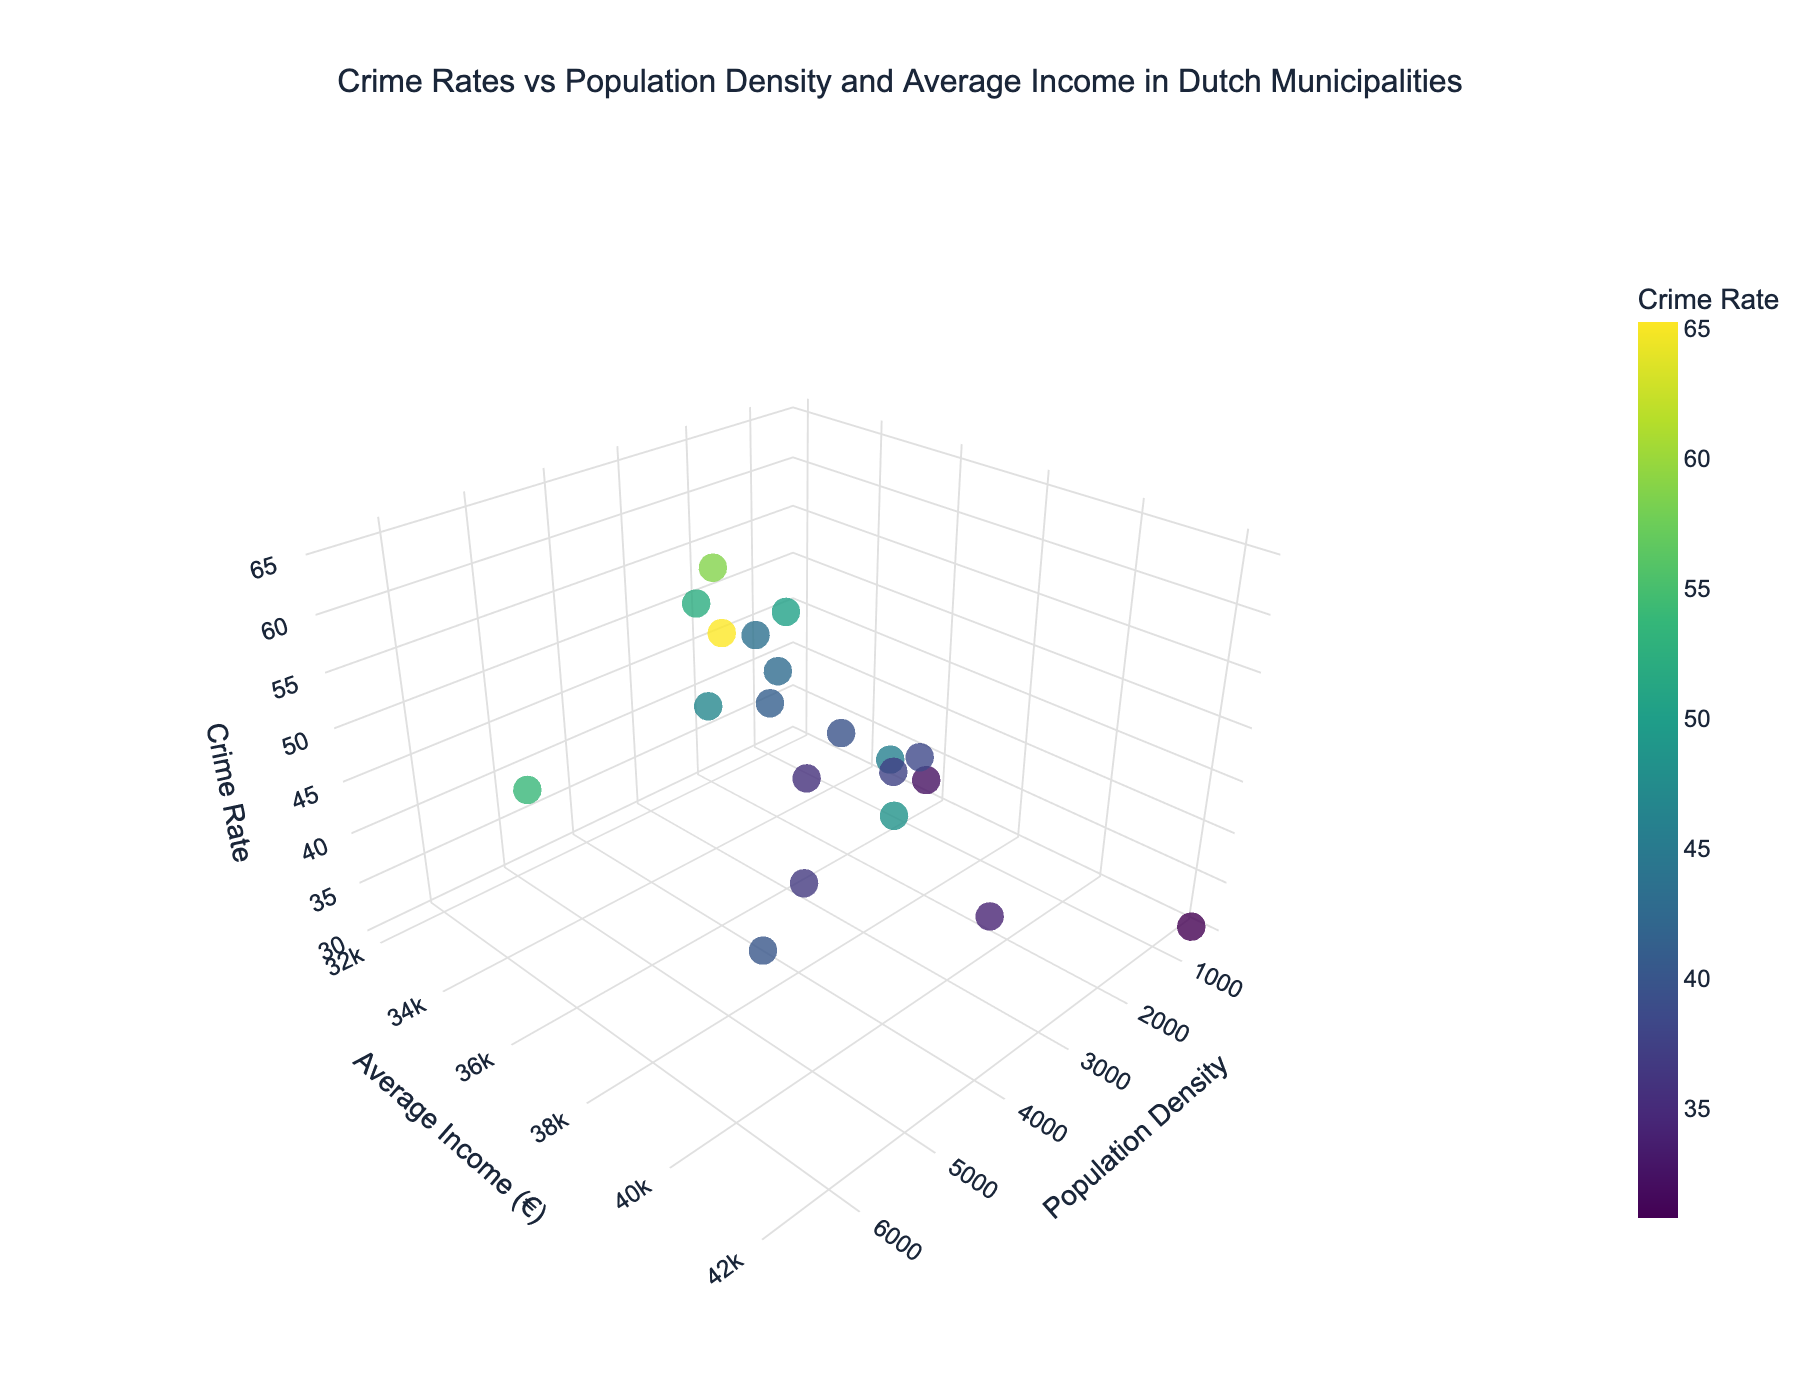What's the title of the figure? The title of the figure is located at the top, centered.
Answer: "Crime Rates vs Population Density and Average Income in Dutch Municipalities" How many data points are shown in the figure? Each municipality represents a single data point. We can count the municipalities listed in the data.
Answer: 20 Which municipality has the highest crime rate? By observing the highest point on the Crime Rate (z-axis), we can identify it by its label or color.
Answer: Amsterdam What is the crime rate in Utrecht? Find the data point labeled "Utrecht" and check its position on the Crime Rate (z-axis) or refer to the color bar.
Answer: 48.3 Which municipality has the lowest average income? Look for the lowest value on the Average Income (y-axis) and identify the corresponding municipality.
Answer: Enschede Is there any municipality with a population density over 5000 people per km²? Check the x-axis for values above 5000 and identify the corresponding municipalities.
Answer: Yes, Amsterdam and The Hague Which two municipalities have a similar population density but different average incomes? Compare the x-axis values for proximity and check their respective y-axes.
Answer: Rotterdam and Eindhoven What is the average crime rate of municipalities with an average income above €40,000? Identify municipalities with y-axis values above 40,000 and then calculate the average of their z-axis values.
Answer: Amersfoort and Haarlemmermeer; Average crime rate: (34.2 + 30.8) / 2 = 32.5 Do higher-income municipalities generally have lower crime rates? Observe the trend between the y-axis (income) and the z-axis (crime rate).
Answer: Generally, yes Which municipality has the highest population density and what is its crime rate? Identify the highest value on the x-axis and check its corresponding z-axis value.
Answer: The Hague, with a crime rate of 53.9 